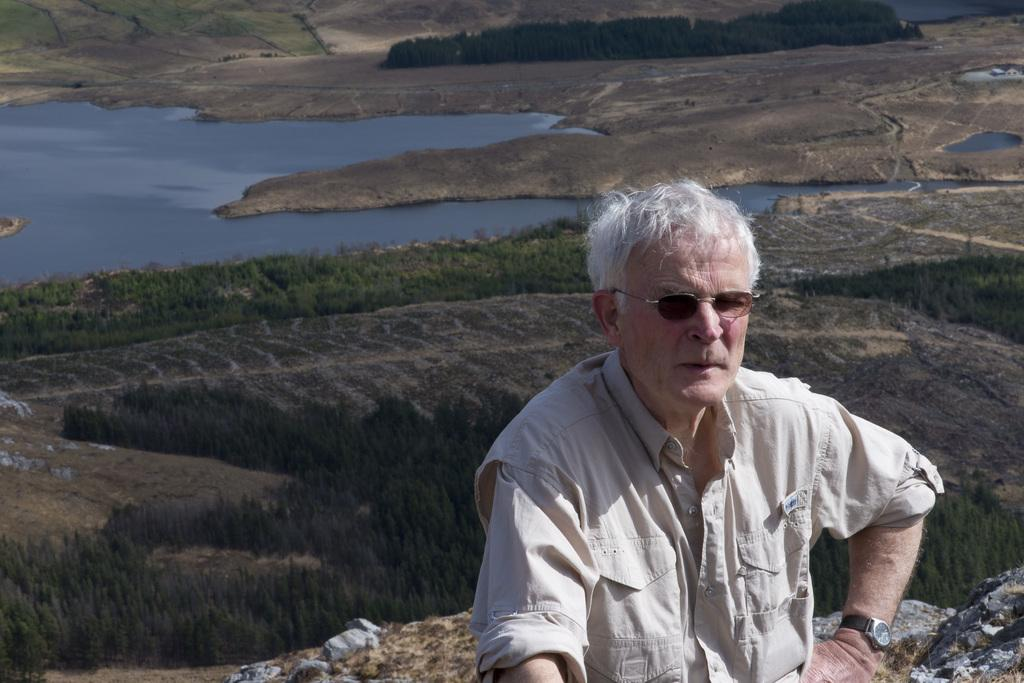What is located on the right side of the image? There is a man on the right side of the image. What is the man wearing on his upper body? The man is wearing a shirt. What accessory is the man wearing on his face? The man is wearing spectacles. What can be seen in the background of the image? There appears to be a pond and trees in the background of the image. What type of religious observation is taking place in the image? There is no indication of any religious observation in the image. What is the man using to make observations in the image? The man is not using any specific tool for observation in the image; he is simply standing there wearing spectacles. 